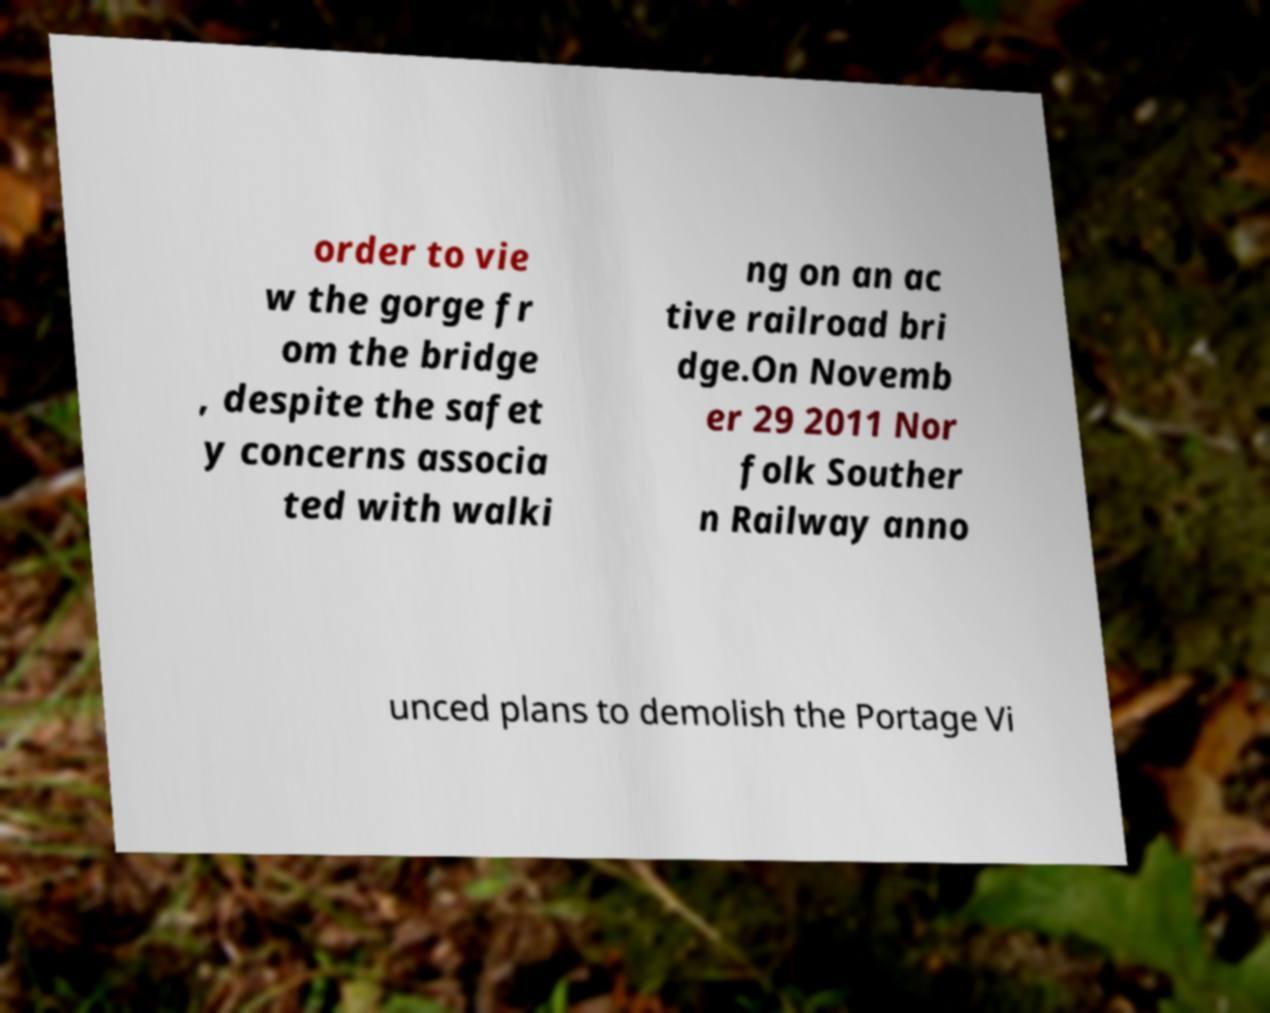Can you read and provide the text displayed in the image?This photo seems to have some interesting text. Can you extract and type it out for me? order to vie w the gorge fr om the bridge , despite the safet y concerns associa ted with walki ng on an ac tive railroad bri dge.On Novemb er 29 2011 Nor folk Souther n Railway anno unced plans to demolish the Portage Vi 